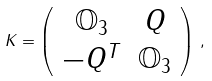<formula> <loc_0><loc_0><loc_500><loc_500>K = \left ( \begin{array} { c c } \mathbb { O } _ { 3 } & Q \\ - Q ^ { T } & \mathbb { O } _ { 3 } \\ \end{array} \right ) \, ,</formula> 